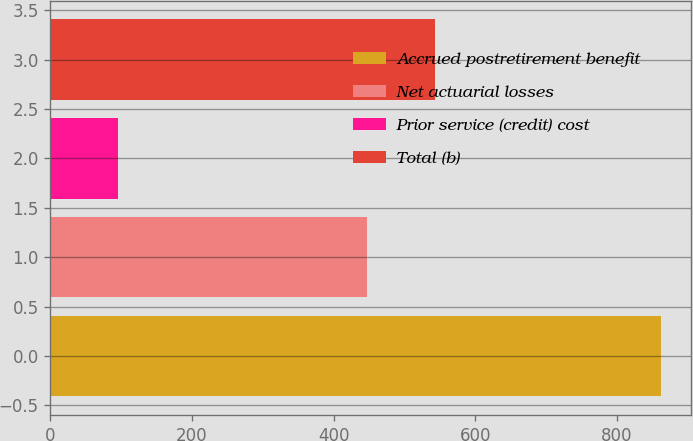Convert chart to OTSL. <chart><loc_0><loc_0><loc_500><loc_500><bar_chart><fcel>Accrued postretirement benefit<fcel>Net actuarial losses<fcel>Prior service (credit) cost<fcel>Total (b)<nl><fcel>862<fcel>447<fcel>96<fcel>543<nl></chart> 